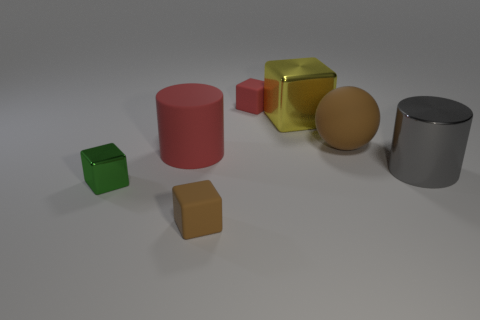Is there a small red thing made of the same material as the green thing?
Keep it short and to the point. No. There is a big rubber object that is in front of the brown ball; does it have the same color as the small shiny cube?
Your answer should be compact. No. Is the number of green metal things that are behind the big gray shiny object the same as the number of big blue metallic spheres?
Offer a very short reply. Yes. Are there any objects of the same color as the large rubber ball?
Offer a terse response. Yes. Do the ball and the gray shiny thing have the same size?
Ensure brevity in your answer.  Yes. There is a brown thing in front of the shiny thing left of the red cylinder; what is its size?
Offer a very short reply. Small. There is a block that is behind the large gray metal cylinder and on the left side of the yellow block; what size is it?
Offer a terse response. Small. How many cylinders have the same size as the yellow metal cube?
Provide a short and direct response. 2. How many metal things are either small green spheres or big gray cylinders?
Make the answer very short. 1. What is the material of the brown object that is behind the big matte object that is left of the brown rubber block?
Give a very brief answer. Rubber. 